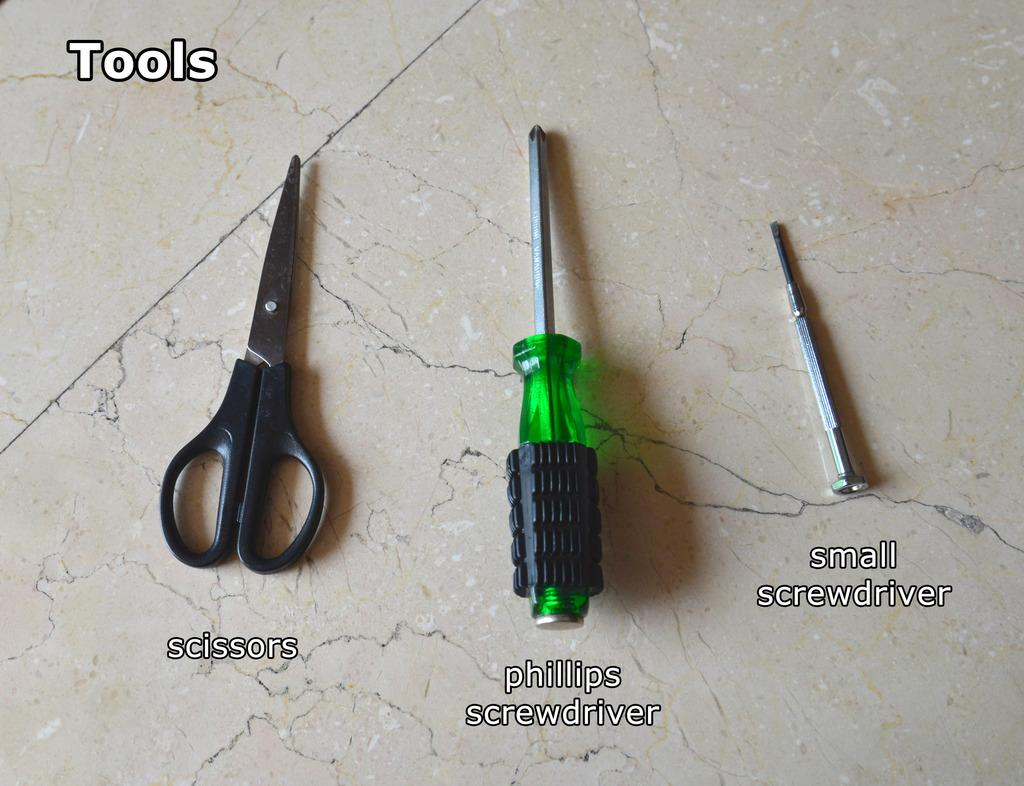What tools are on the floor in the image? There is a scissors and a screwdriver on the floor in the image. Are there any other tools visible on the floor? Yes, there is a small screwdriver on the floor. What can be seen at the top of the image? There is text at the top of the image. What can be seen at the bottom of the image? There is text at the bottom of the image. What type of tooth is visible in the image? There is no tooth present in the image. Is there a veil covering any of the tools in the image? No, there is no veil present in the image. 